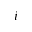<formula> <loc_0><loc_0><loc_500><loc_500>i</formula> 